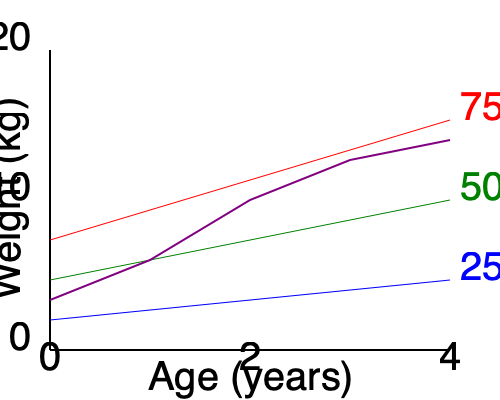Based on the growth chart provided, which percentile does the child's weight most closely follow from age 2 to 4 years? To interpret the child's growth chart and determine which percentile the child's weight most closely follows from age 2 to 4 years, we need to analyze the purple line representing the child's growth in relation to the percentile curves. Let's break it down step-by-step:

1. Identify the percentile curves:
   - Blue curve: 25th percentile
   - Green curve: 50th percentile
   - Red curve: 75th percentile

2. Locate the child's growth line (purple) on the chart.

3. Focus on the age range from 2 to 4 years:
   - At age 2 (middle of x-axis), the child's weight is slightly below the green 50th percentile line.
   - Between ages 2 and 4, the child's growth line crosses and stays above the green 50th percentile line.
   - At age 4 (right end of x-axis), the child's weight is between the green 50th percentile and the red 75th percentile lines, but closer to the 50th.

4. Analyze the overall trend:
   - The child's growth line starts slightly below the 50th percentile at age 2.
   - It then crosses and remains above the 50th percentile line.
   - The line ends closer to the 50th percentile than the 75th percentile at age 4.

5. Conclusion:
   Although the child's weight shows some variation, it most closely follows the 50th percentile from age 2 to 4 years. The growth line remains near the 50th percentile curve throughout this period, despite some fluctuation.
Answer: 50th percentile 